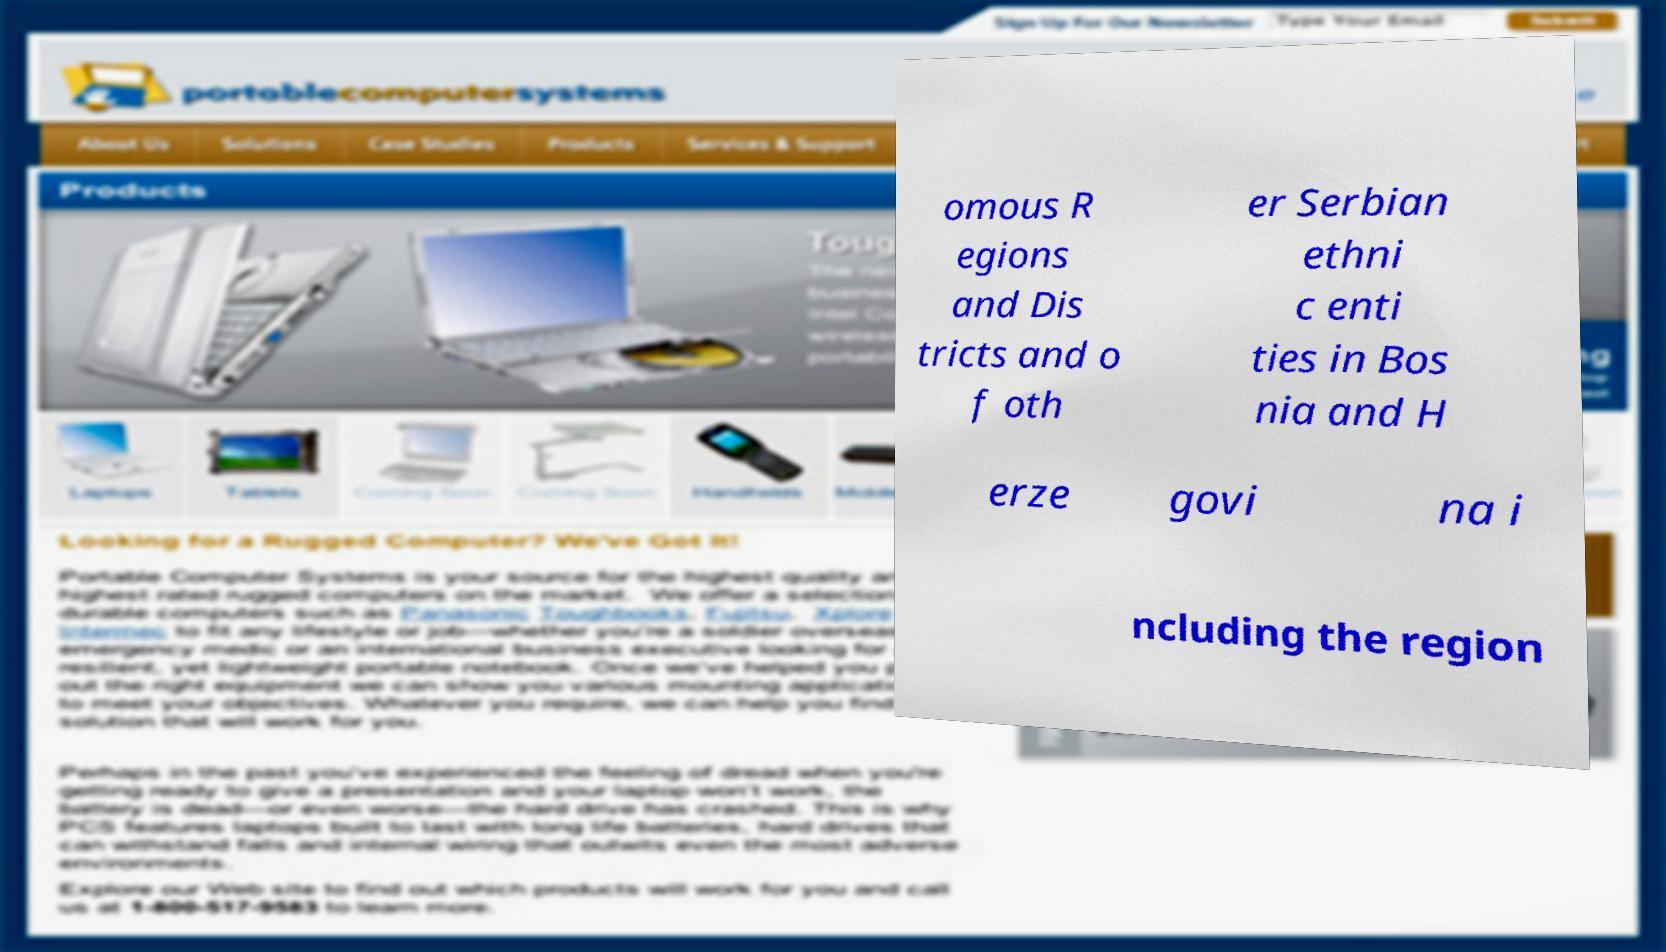There's text embedded in this image that I need extracted. Can you transcribe it verbatim? omous R egions and Dis tricts and o f oth er Serbian ethni c enti ties in Bos nia and H erze govi na i ncluding the region 